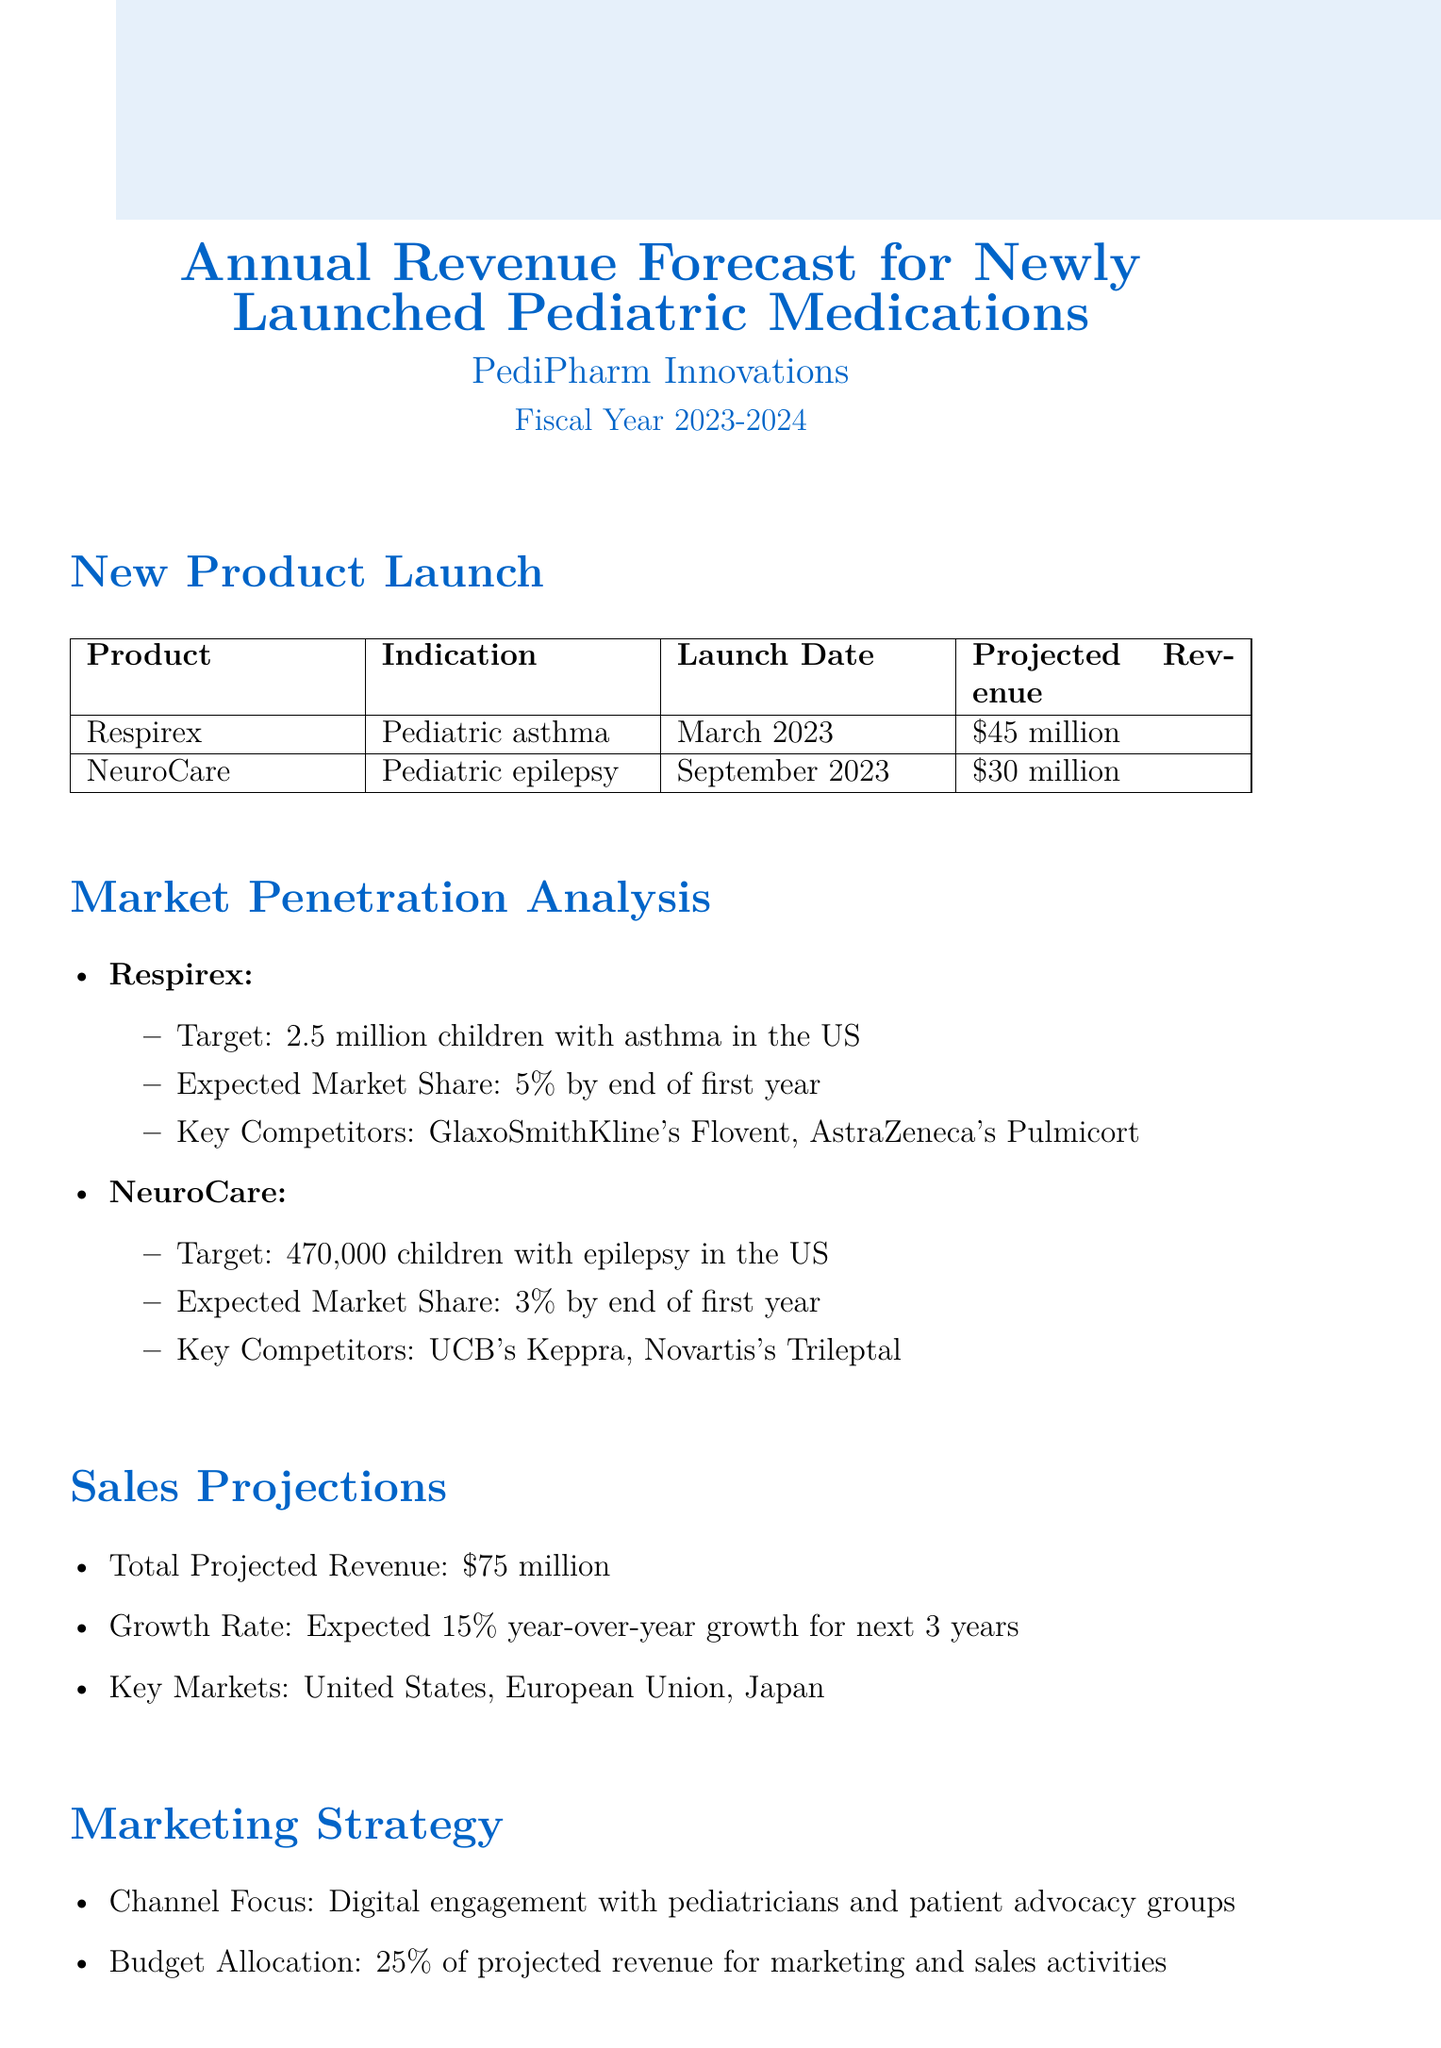What is the projected first-year revenue for Respirex? The projected first-year revenue for Respirex, as mentioned in the document, is $45 million.
Answer: $45 million What is the target patient population for NeuroCare? The target patient population for NeuroCare is stated as 470,000 children with epilepsy in the US.
Answer: 470,000 children What is the expected market share for Respirex by the end of the first year? The document indicates that Respirex is expected to achieve a 5% market share by the end of its first year.
Answer: 5% Which company is listed as a key competitor for NeuroCare? The document lists UCB's Keppra and Novartis's Trileptal as key competitors for NeuroCare.
Answer: UCB's Keppra What is the total projected revenue for both products combined? The total projected revenue for both products is given as $75 million in the document.
Answer: $75 million What is the expected year-over-year growth rate for the next three years? According to the document, the expected year-over-year growth rate is 15% for the next three years.
Answer: 15% What percentage of projected revenue is allocated to marketing and sales activities? The document states that 25% of projected revenue is allocated for marketing and sales activities.
Answer: 25% What are two risk factors mentioned in the report? The document lists regulatory delays in key markets and unexpected safety concerns in pediatric populations as risk factors.
Answer: Regulatory delays, unexpected safety concerns When was Respirex launched? The launch date for Respirex is highlighted in the document as March 2023.
Answer: March 2023 